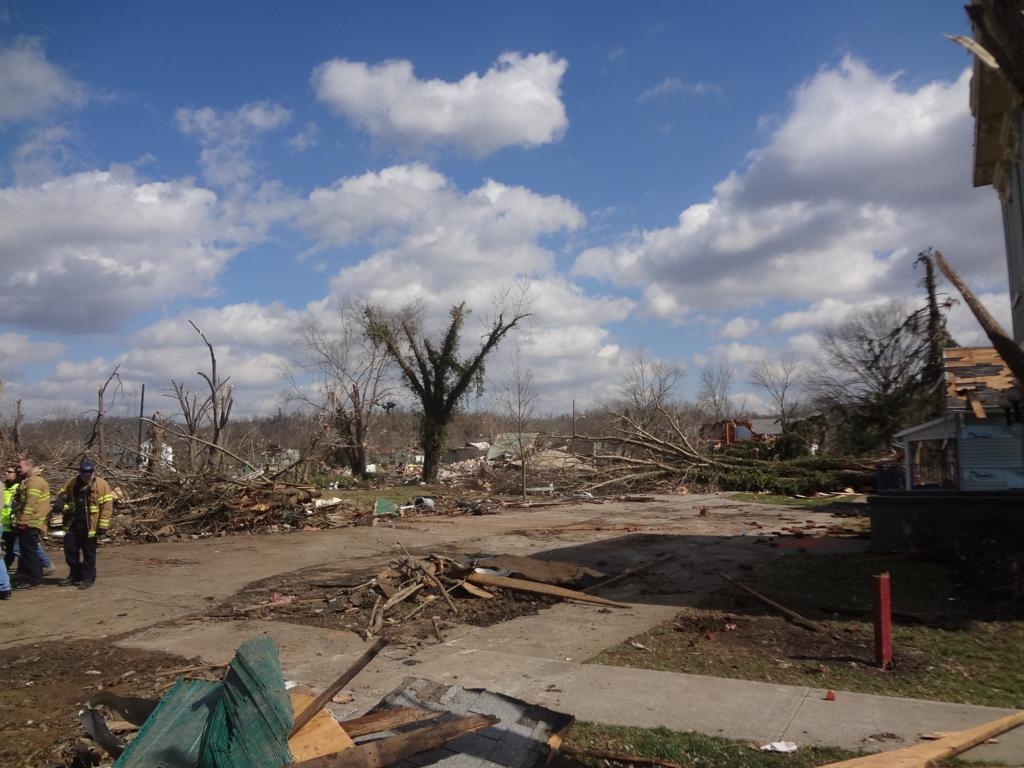What type of vegetation is present in the image? There are dry trees in the image. Where are the people located in the image? The people are on the left side of the image. What structure can be seen on the right side of the image? There is a house on the right side of the image. What is visible at the top of the image? The sky is visible at the top of the image. What type of pipe is being used to sound the alarm in the image? There is no pipe or alarm present in the image. How does the comparison between the trees and the house in the image affect the overall composition? There is no comparison being made between the trees and the house in the image, as the conversation focuses on the individual elements and their locations. 